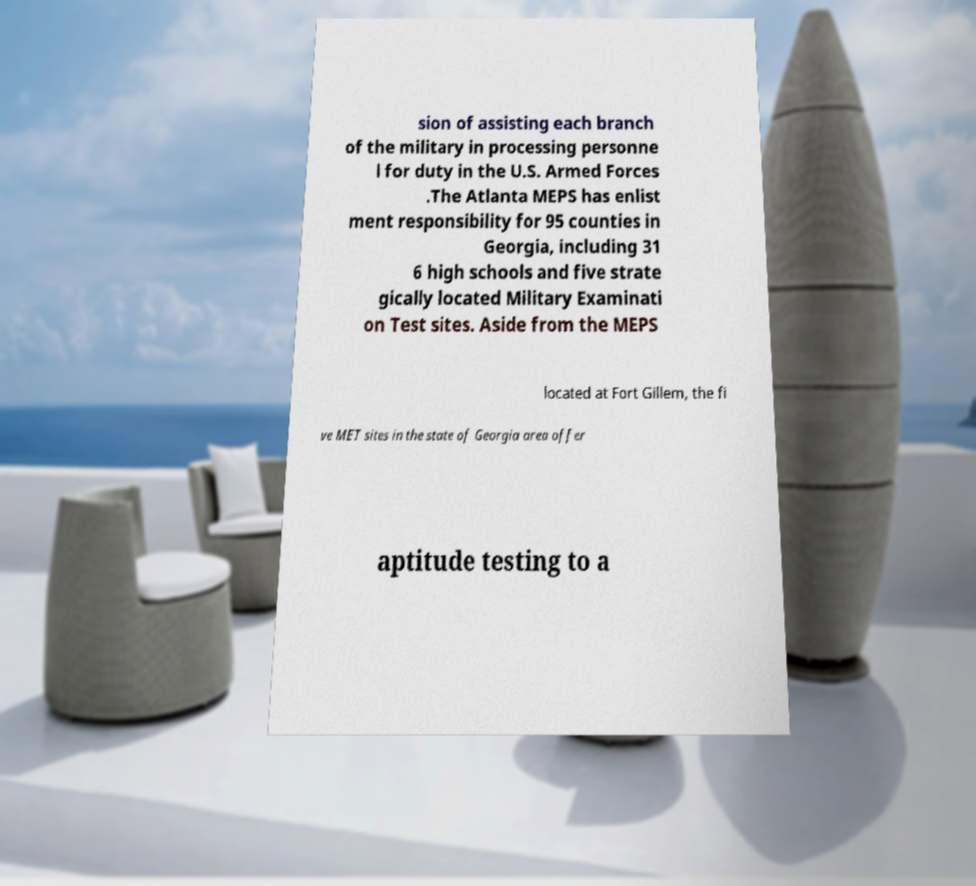For documentation purposes, I need the text within this image transcribed. Could you provide that? sion of assisting each branch of the military in processing personne l for duty in the U.S. Armed Forces .The Atlanta MEPS has enlist ment responsibility for 95 counties in Georgia, including 31 6 high schools and five strate gically located Military Examinati on Test sites. Aside from the MEPS located at Fort Gillem, the fi ve MET sites in the state of Georgia area offer aptitude testing to a 